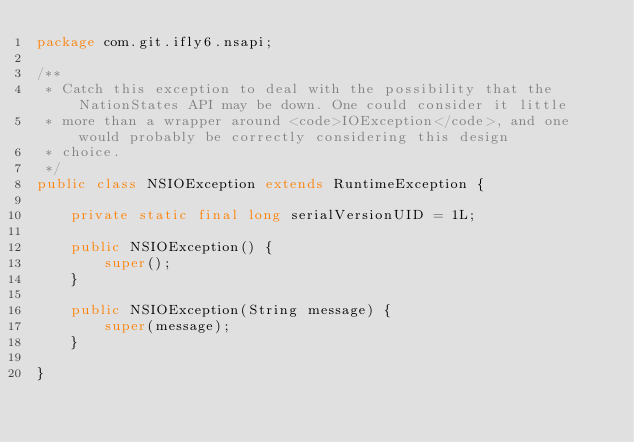<code> <loc_0><loc_0><loc_500><loc_500><_Java_>package com.git.ifly6.nsapi;

/**
 * Catch this exception to deal with the possibility that the NationStates API may be down. One could consider it little
 * more than a wrapper around <code>IOException</code>, and one would probably be correctly considering this design
 * choice.
 */
public class NSIOException extends RuntimeException {

	private static final long serialVersionUID = 1L;

	public NSIOException() {
		super();
	}

	public NSIOException(String message) {
		super(message);
	}

}
</code> 